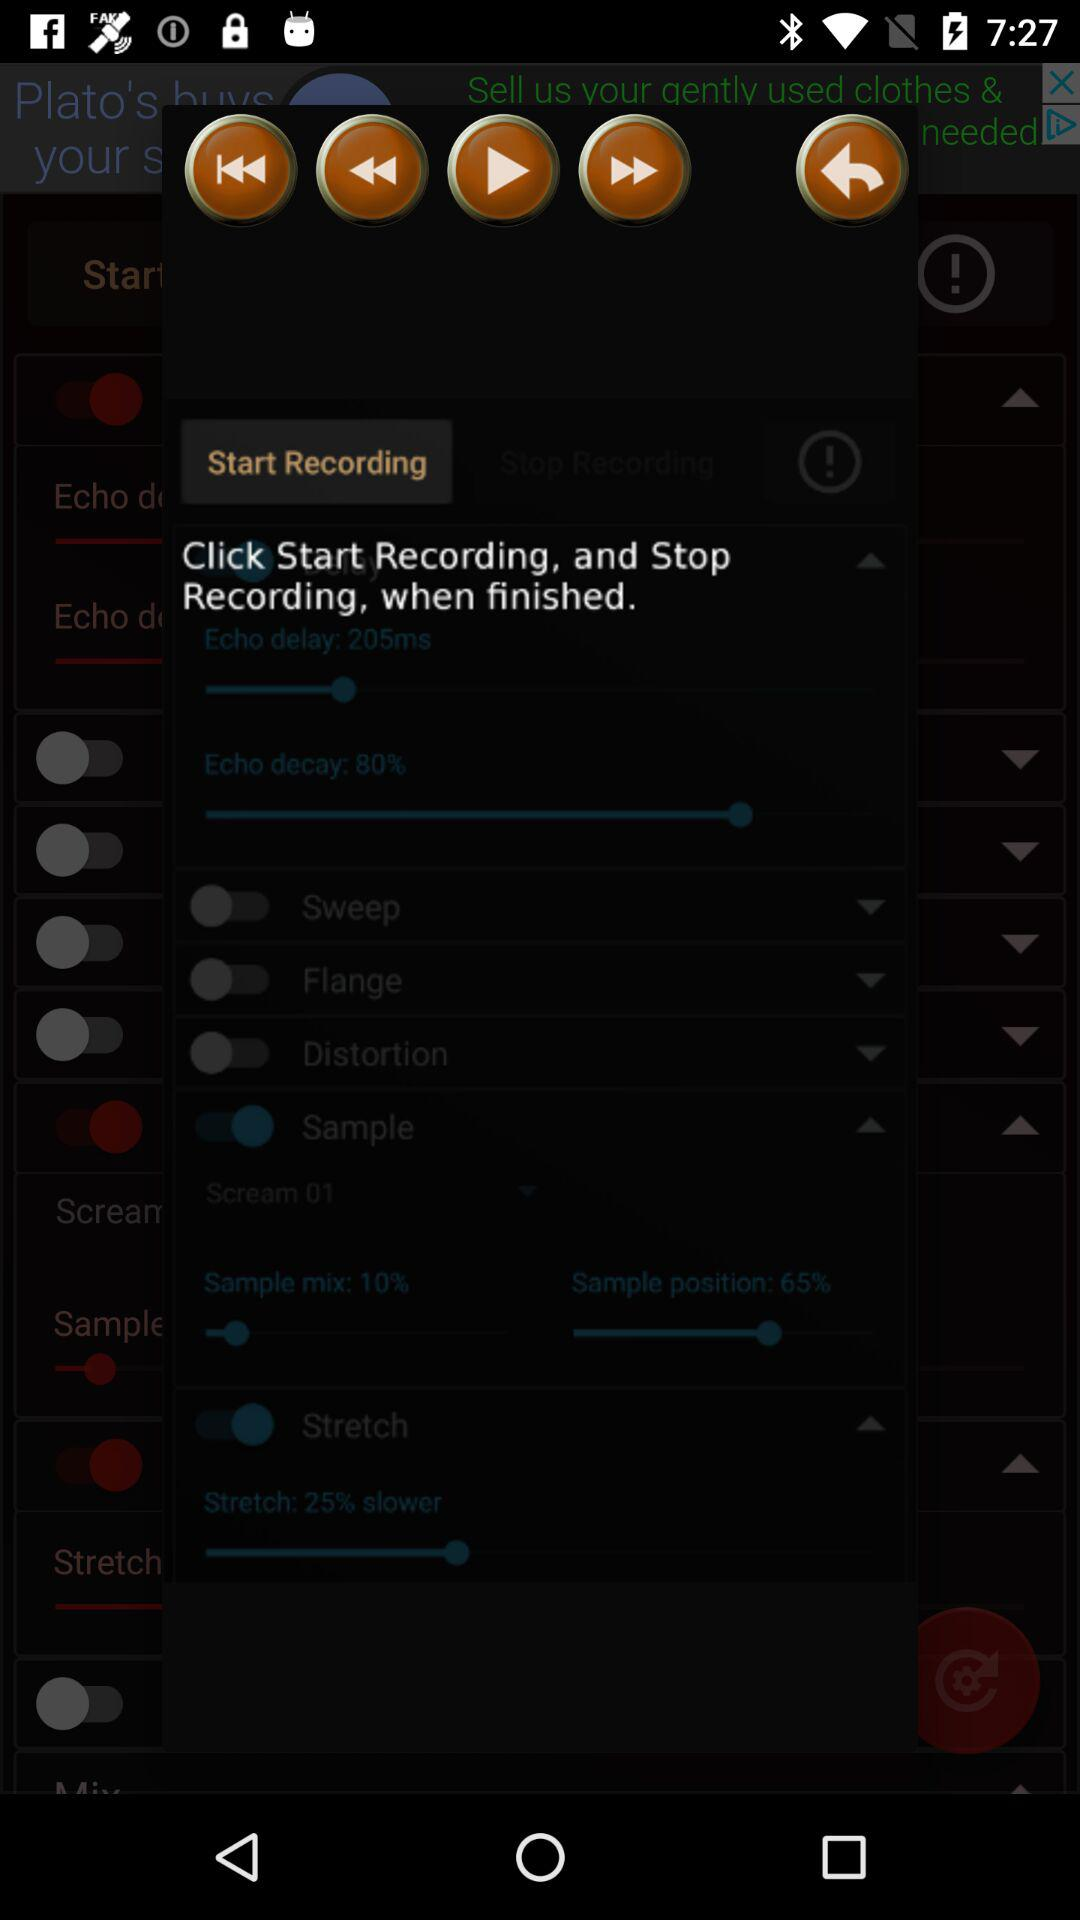What is the sample position percentage? The sample position percentage is 65. 